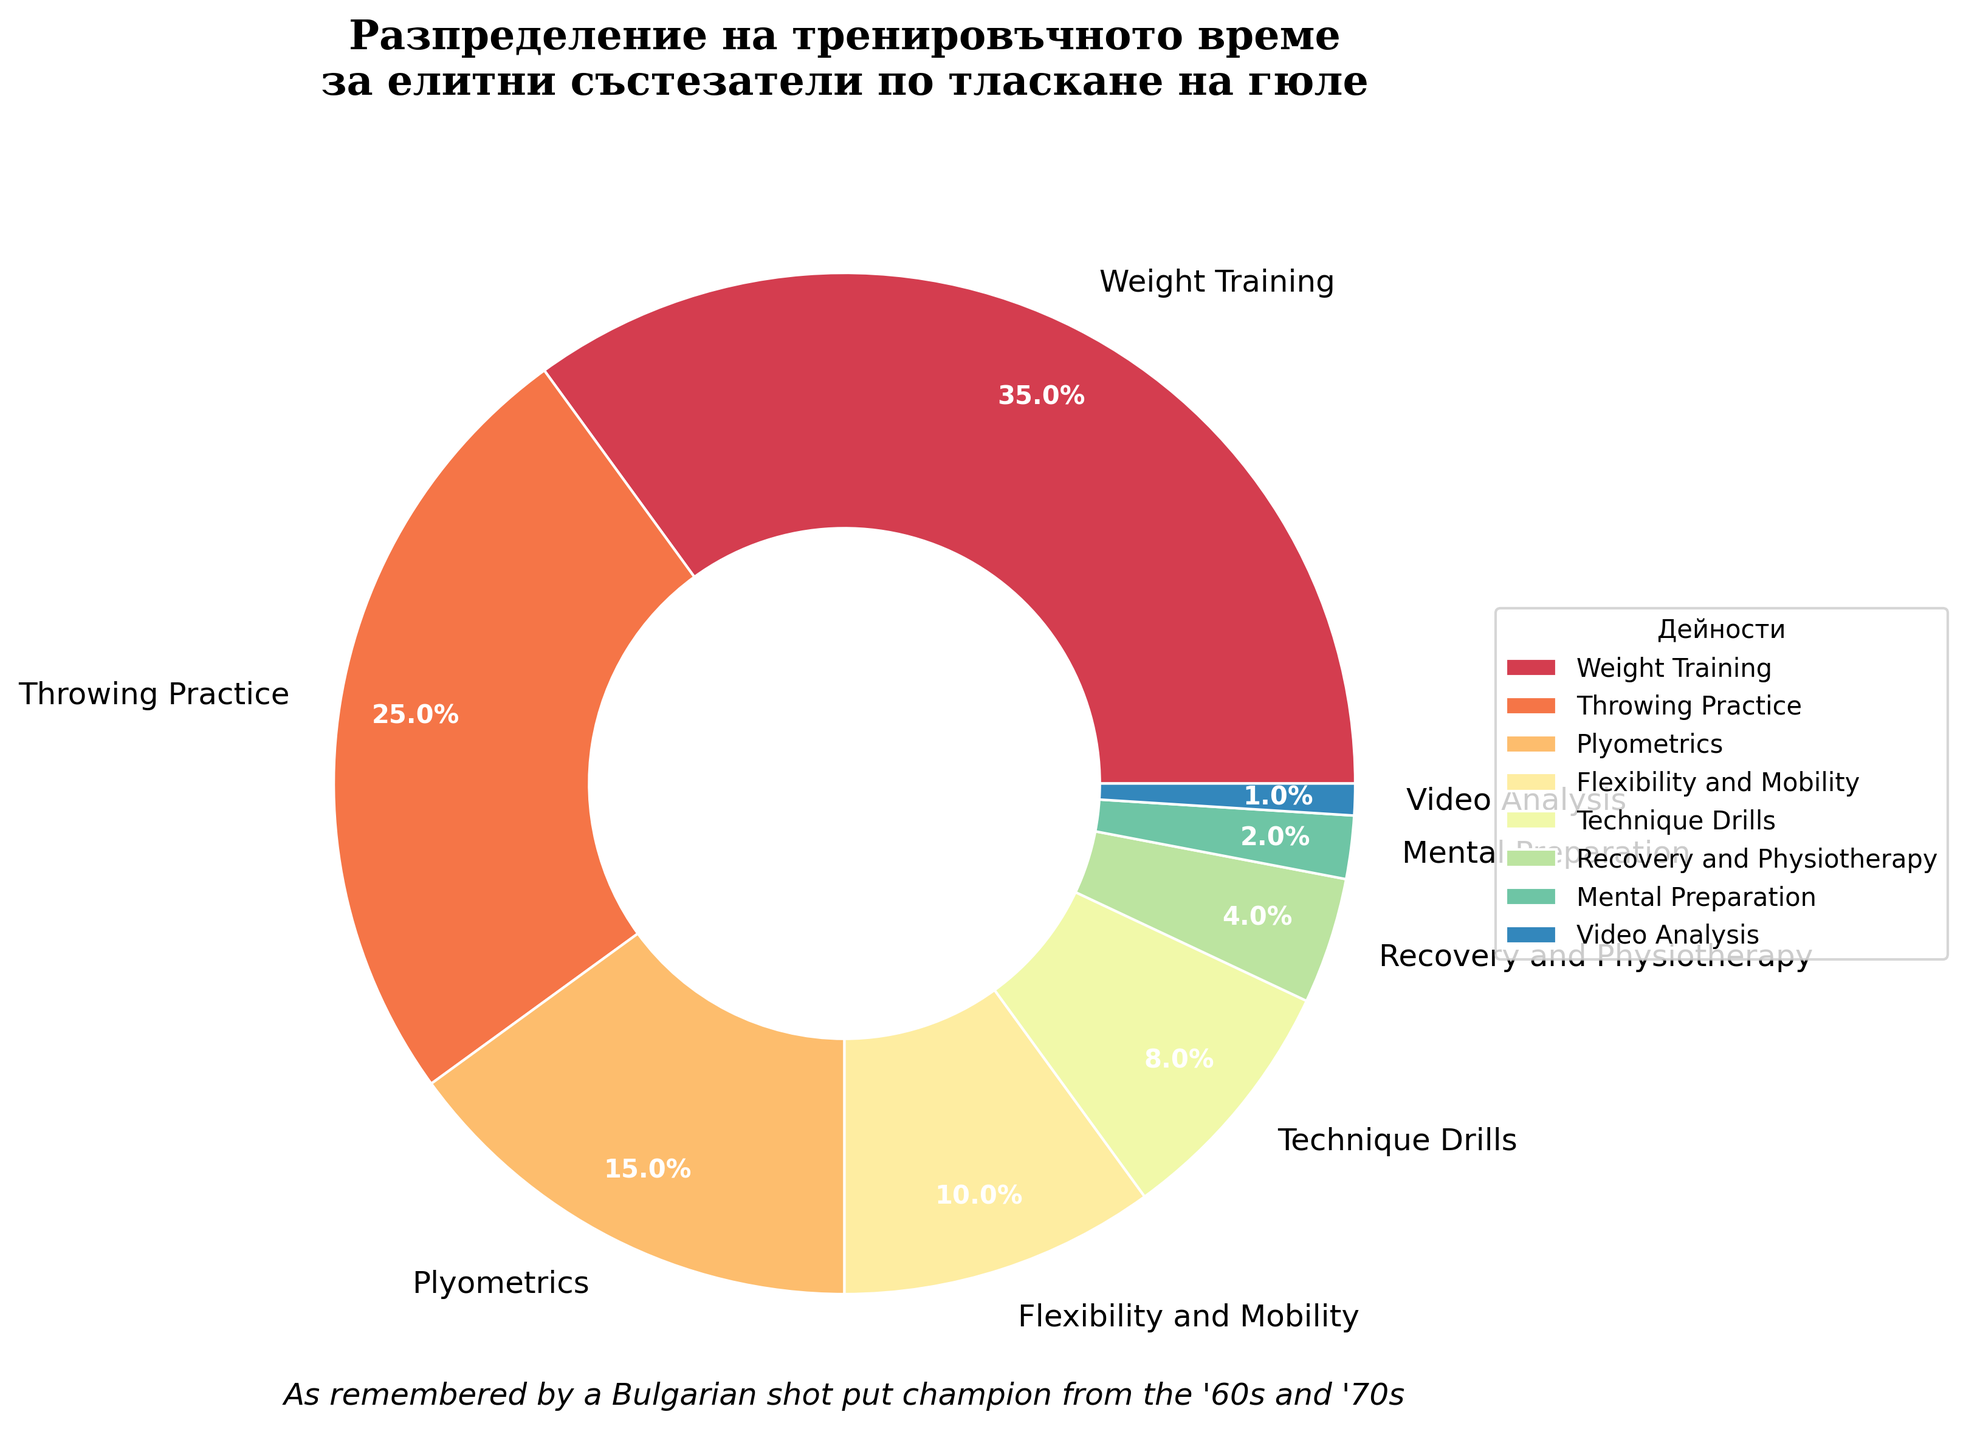Which activity takes up the largest percentage of training time? By observing the figure, we notice that the largest wedge represents Weight Training with the largest percentage.
Answer: Weight Training Which two activities combined have the same training time percentage as Plyometrics? Plyometrics occupies 15% of the training time. The combined percentage of Flexibility and Mobility (10%) and Mental Preparation (2%) sums up to 12%, which is less than 15%. However, Technique Drills (8%) and Video Analysis (1%) sum up to 9%, which isn't sufficient either. We have to find two different activities whose total reaches exactly 15%, which are Throwing Practice (25%) minus Flexibility and Mobility (10%).
Answer: Flexibility and Mobility and Technique Drills How much more time is allocated to Weight Training compared to Plyometrics? Weight Training is allocated 35%, while Plyometrics is allocated 15%. The difference is calculated as 35% - 15%.
Answer: 20% What is the total percentage of time allocated to all activities marked under 10%? Observing the chart, activities under 10% are Flexibility and Mobility (10%), Technique Drills (8%), Recovery and Physiotherapy (4%), Mental Preparation (2%), and Video Analysis (1%). Summing these yields 10 + 8 + 4 + 2 + 1 = 25%.
Answer: 25% Are more training hours allocated to Recovery and Physiotherapy or Video Analysis? Comparing the chart sections, Recovery and Physiotherapy (4%) is a larger percentage than Video Analysis (1%).
Answer: Recovery and Physiotherapy What is the percentage difference between the two activities with the smallest time allocation? The smallest percentages are Mental Preparation (2%) and Video Analysis (1%). The difference is calculated as 2% - 1%.
Answer: 1% Which segments of the pie chart are represented by warm colors? Warm colors in the figure include red, orange, and yellow. The wedges colored in these tones represent Weight Training and Flexibility and Mobility.
Answer: Weight Training and Flexibility and Mobility What is the cumulative percentage of time spent on activities that involve physical movement? Activities involving physical movement are Weight Training (35%), Throwing Practice (25%), Plyometrics (15%), and Technique Drills (8%). Summing these gives 35 + 25 + 15 + 8 = 83%.
Answer: 83% What portion of the chart is dedicated to video-related analysis? By examining the chart, 1% of the chart is allocated to Video Analysis.
Answer: 1% If the total training time is 20 hours per week, how many hours per week are spent on Throwing Practice? Throwing Practice is allocated 25% of the training time. To find the hours, calculate 25% of 20 hours. 25% of 20 is (25/100) * 20 = 5 hours per week.
Answer: 5 hours per week 